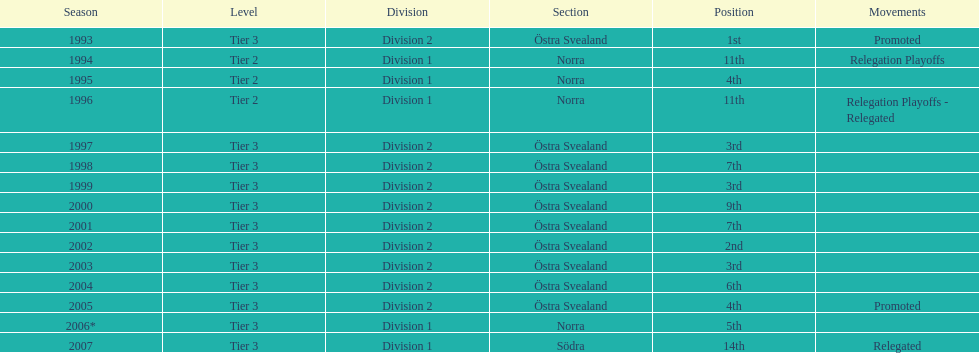In what season did visby if gute fk secure the top position in division 2 tier 3? 1993. 